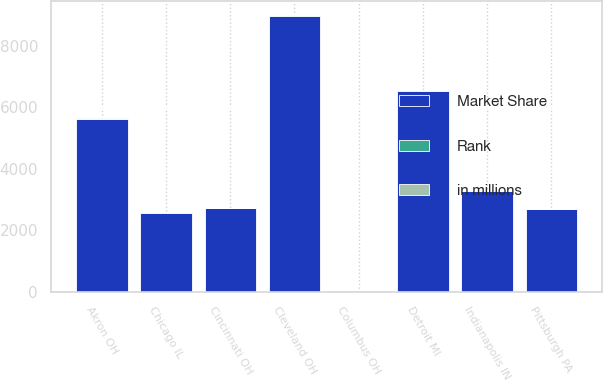<chart> <loc_0><loc_0><loc_500><loc_500><stacked_bar_chart><ecel><fcel>Columbus OH<fcel>Cleveland OH<fcel>Detroit MI<fcel>Akron OH<fcel>Indianapolis IN<fcel>Cincinnati OH<fcel>Pittsburgh PA<fcel>Chicago IL<nl><fcel>Rank<fcel>1<fcel>5<fcel>7<fcel>1<fcel>4<fcel>4<fcel>9<fcel>16<nl><fcel>Market Share<fcel>9<fcel>8976<fcel>6542<fcel>5611<fcel>3272<fcel>2727<fcel>2689<fcel>2581<nl><fcel>in millions<fcel>32<fcel>14<fcel>5<fcel>39<fcel>7<fcel>3<fcel>2<fcel>1<nl></chart> 